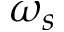<formula> <loc_0><loc_0><loc_500><loc_500>\omega _ { s }</formula> 